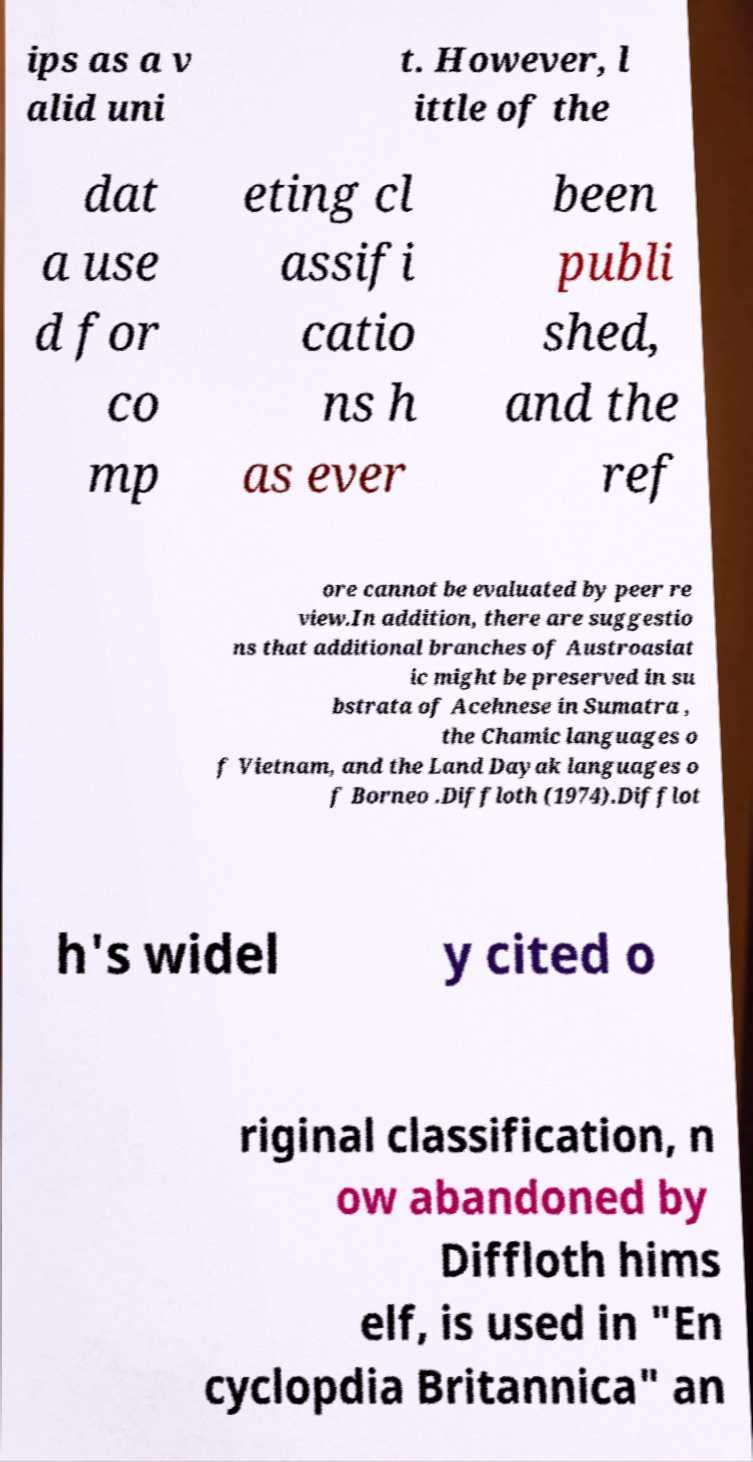Please read and relay the text visible in this image. What does it say? ips as a v alid uni t. However, l ittle of the dat a use d for co mp eting cl assifi catio ns h as ever been publi shed, and the ref ore cannot be evaluated by peer re view.In addition, there are suggestio ns that additional branches of Austroasiat ic might be preserved in su bstrata of Acehnese in Sumatra , the Chamic languages o f Vietnam, and the Land Dayak languages o f Borneo .Diffloth (1974).Difflot h's widel y cited o riginal classification, n ow abandoned by Diffloth hims elf, is used in "En cyclopdia Britannica" an 